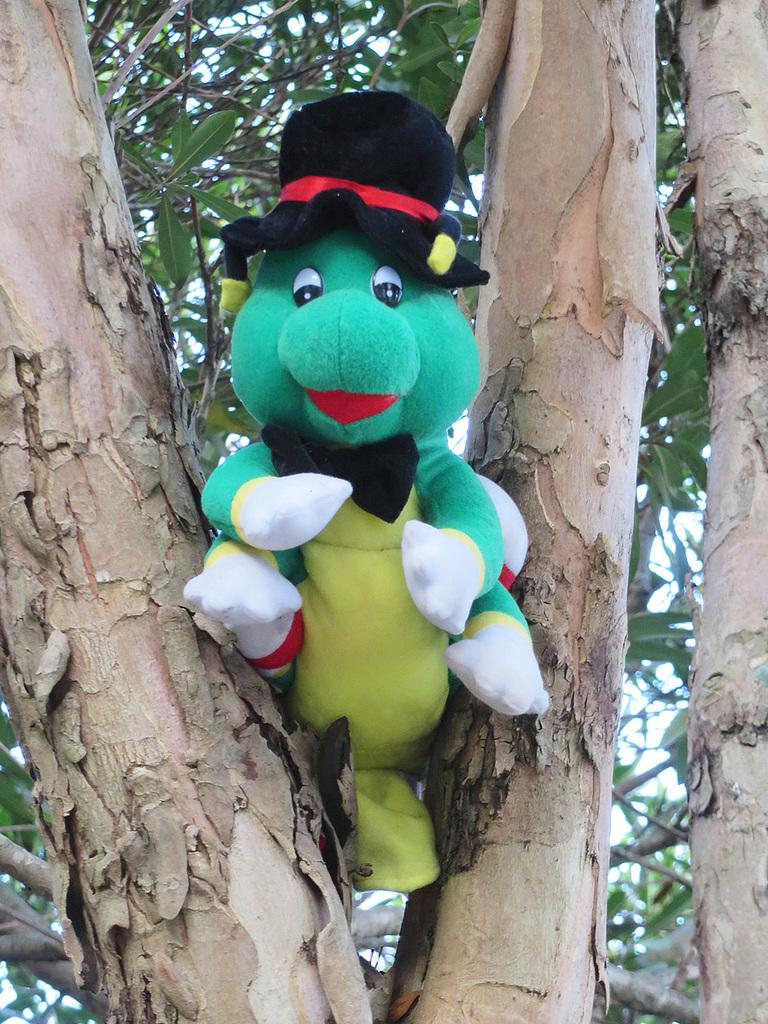What is the main subject of the image? There is a doll in the image. Can you describe the appearance of the doll? The doll is colorful. Where is the doll located in the image? The doll is on a tree. What can be seen in the background of the image? The sky is visible in the background of the image. How many chickens are sitting on the cup in the image? There are no chickens or cups present in the image; it features a colorful doll on a tree. What type of bucket is being used to catch the rain in the image? There is no bucket or rain present in the image. 